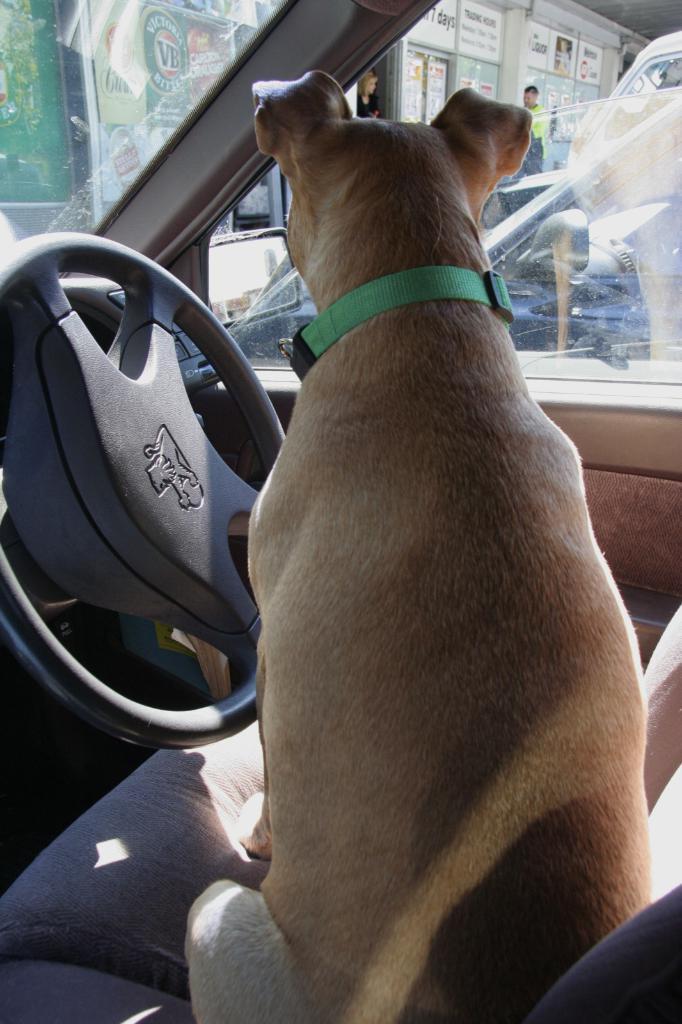In one or two sentences, can you explain what this image depicts? In the center we can see dog sitting in the car. And back we can see some shop and few persons were standing,and some vehicles. 